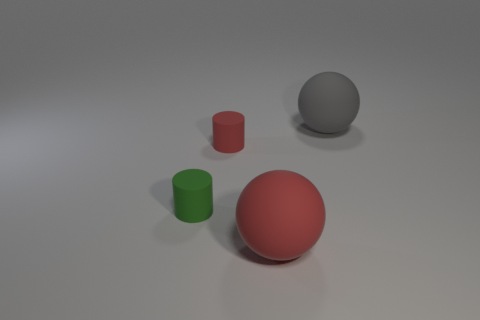There is a large gray object that is the same material as the big red ball; what is its shape?
Offer a very short reply. Sphere. Is the size of the red matte ball the same as the gray thing?
Your response must be concise. Yes. Do the ball that is behind the big red matte ball and the red cylinder have the same material?
Offer a very short reply. Yes. Is there any other thing that is made of the same material as the green thing?
Your answer should be very brief. Yes. There is a sphere that is on the left side of the object to the right of the big red ball; how many small red things are right of it?
Make the answer very short. 0. Is the shape of the large thing that is behind the tiny green thing the same as  the big red thing?
Make the answer very short. Yes. How many objects are small green rubber cylinders or large rubber balls that are left of the large gray rubber thing?
Offer a terse response. 2. Is the number of small red rubber cylinders that are behind the large red rubber sphere greater than the number of small gray shiny things?
Give a very brief answer. Yes. Are there an equal number of small red cylinders right of the large red sphere and small cylinders in front of the red cylinder?
Your answer should be compact. No. There is a tiny green matte thing behind the big red rubber ball; are there any balls that are behind it?
Provide a succinct answer. Yes. 